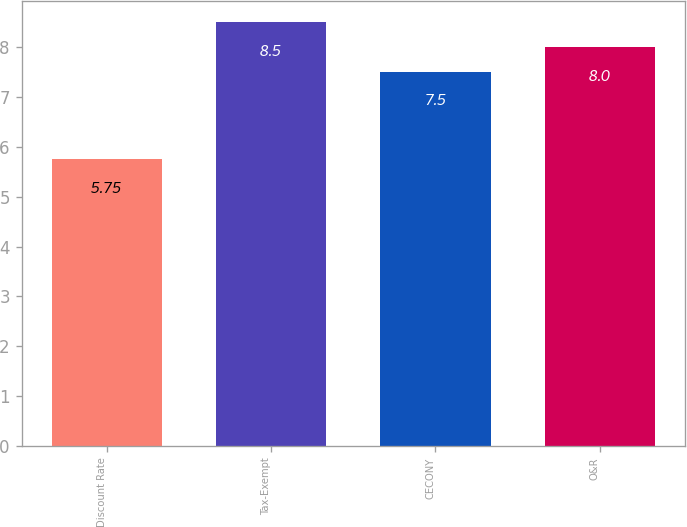<chart> <loc_0><loc_0><loc_500><loc_500><bar_chart><fcel>Discount Rate<fcel>Tax-Exempt<fcel>CECONY<fcel>O&R<nl><fcel>5.75<fcel>8.5<fcel>7.5<fcel>8<nl></chart> 